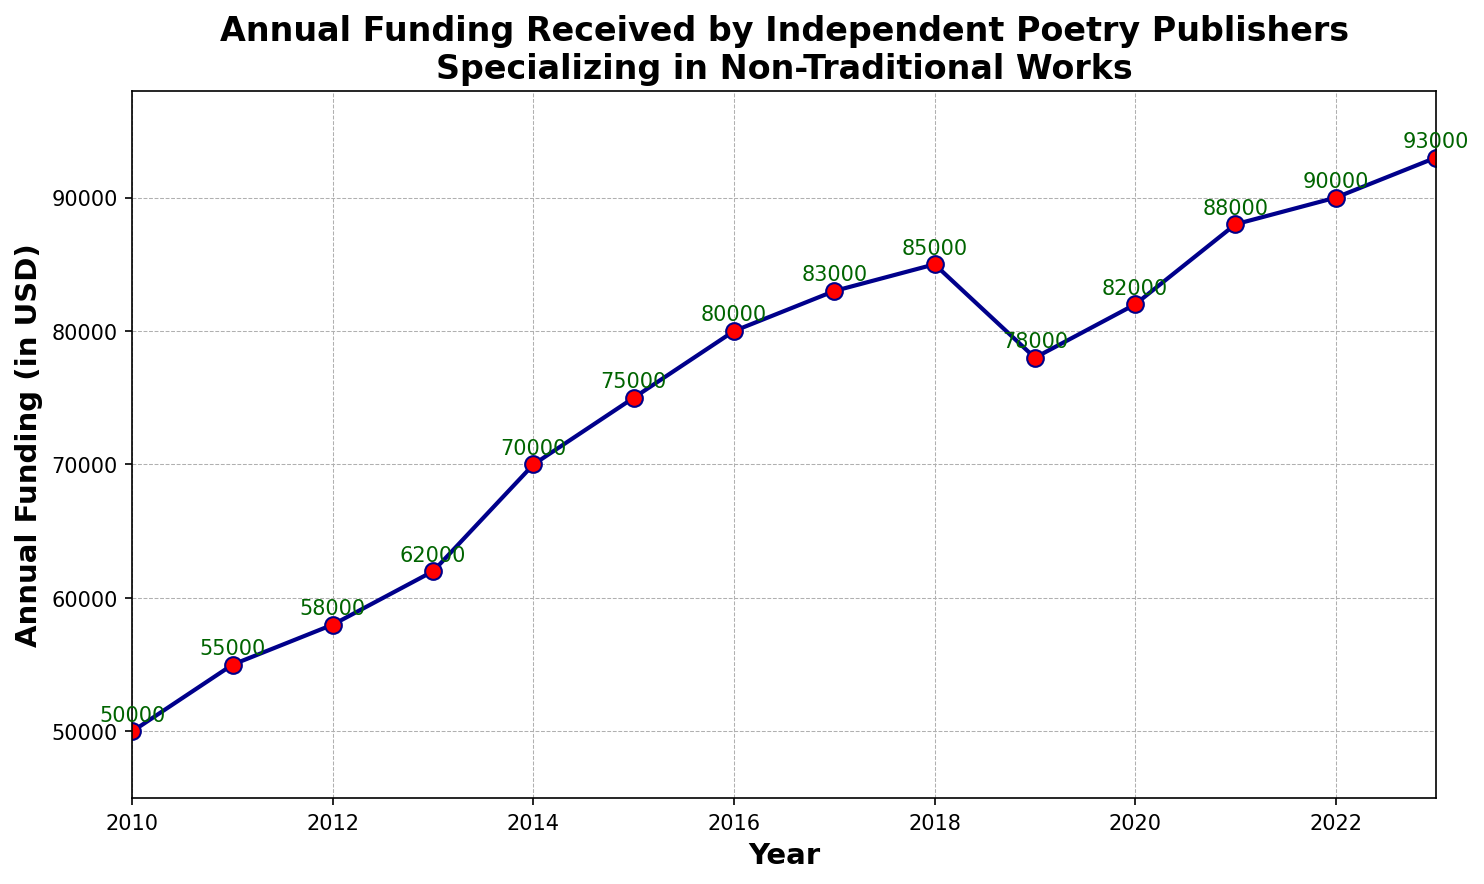What's the trend in annual funding from 2010 to 2023? By observing the line chart, the annual funding shows an upward trend from $50,000 in 2010 to $93,000 in 2023, with minor fluctuations. Overall, the funding has increased over the years.
Answer: Upward trend What's the difference in annual funding between 2010 and 2023? The annual funding in 2010 was $50,000, and in 2023 it was $93,000. The difference is calculated as $93,000 - $50,000 = $43,000.
Answer: $43,000 In which year did the funding experience the largest year-to-year increase? By examining the values for each consecutive year, the largest increase occurs between 2020 ($82,000) and 2021 ($88,000). The increase is $88,000 - $82,000 = $6,000.
Answer: 2021 Was there any year when the funding decreased compared to the previous year? Yes, in 2019, the funding decreased to $78,000 from $85,000 in 2018.
Answer: 2019 What is the average annual funding between 2010 and 2023 inclusive? Add all annual funding values from 2010 to 2023 and divide by the number of years (14 years). Total funding is $1,100,000. The average is $1,100,000 / 14 = $78,571.43.
Answer: $78,571.43 Which year had the highest annual funding? The highest point on the line chart is in 2023 with an annual funding of $93,000.
Answer: 2023 Compare the funding in 2022 to 2016. Which is higher and by how much? The annual funding in 2022 is $90,000, and in 2016, it is $80,000. The difference is $90,000 - $80,000 = $10,000, making 2022 higher.
Answer: 2022 by $10,000 Identify the years where the annual funding was exactly $82,000. From the line chart, the funding was exactly $82,000 in the year 2020.
Answer: 2020 What is the minimum annual funding received during the period shown? The minimum funding visible in the line chart is $50,000 and it occurred in the year 2010.
Answer: $50,000 What is the sum of the annual funding in the first five years (2010-2014)? The annual funding for the years 2010, 2011, 2012, 2013, and 2014 are $50,000, $55,000, $58,000, $62,000, and $70,000 respectively. The sum is $50,000 + $55,000 + $58,000 + $62,000 + $70,000 = $295,000.
Answer: $295,000 